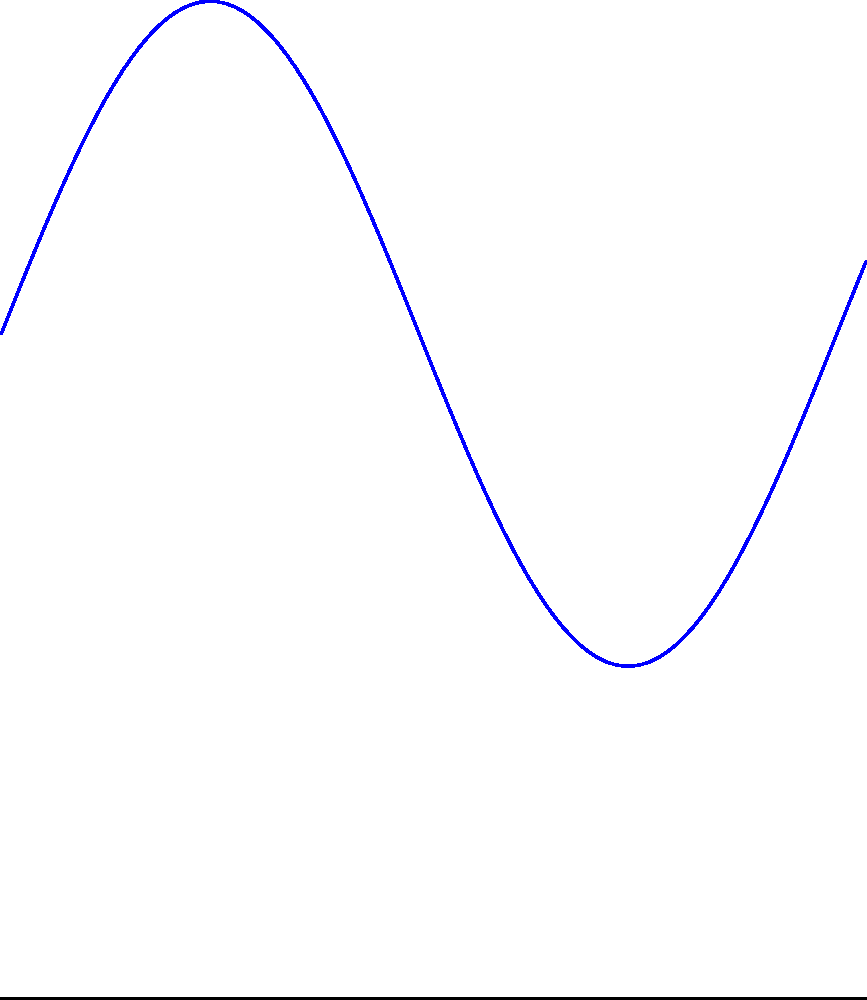As you're analyzing the elevation profile of the 18th hole at Bethpage Black, you notice it follows a sinusoidal curve. The elevation $y$ (in feet) as a function of distance $x$ (in yards) from the tee is given by $y = 10 + 5\sin(\frac{x}{2})$, where $0 \leq x \leq 13$. Calculate the total area under this elevation curve, representing the volume of earth beneath the fairway. To find the area under the curve, we need to integrate the function over the given interval. Here's how we do it:

1) The integral we need to evaluate is:

   $$\int_0^{13} (10 + 5\sin(\frac{x}{2})) dx$$

2) Let's split this into two parts:

   $$\int_0^{13} 10 dx + \int_0^{13} 5\sin(\frac{x}{2}) dx$$

3) The first part is straightforward:

   $$10x\big|_0^{13} = 10(13) - 10(0) = 130$$

4) For the second part, we use the substitution method:
   Let $u = \frac{x}{2}$, then $du = \frac{1}{2}dx$, or $dx = 2du$

   The new limits are: when $x=0$, $u=0$; when $x=13$, $u=\frac{13}{2}$

   $$5\int_0^{\frac{13}{2}} \sin(u) \cdot 2du = 10\int_0^{\frac{13}{2}} \sin(u) du$$

5) We know that $\int \sin(u) du = -\cos(u) + C$, so:

   $$10[-\cos(u)]_0^{\frac{13}{2}} = 10[-\cos(\frac{13}{2}) + \cos(0)]$$

6) $\cos(0) = 1$, so our result is:

   $$10[-\cos(\frac{13}{2}) + 1]$$

7) Adding this to our result from step 3:

   $$130 + 10[-\cos(\frac{13}{2}) + 1]$$

8) Simplifying:

   $$130 + 10 - 10\cos(\frac{13}{2}) = 140 - 10\cos(\frac{13}{2})$$

This represents the area under the curve in square yards.
Answer: $140 - 10\cos(\frac{13}{2})$ square yards 